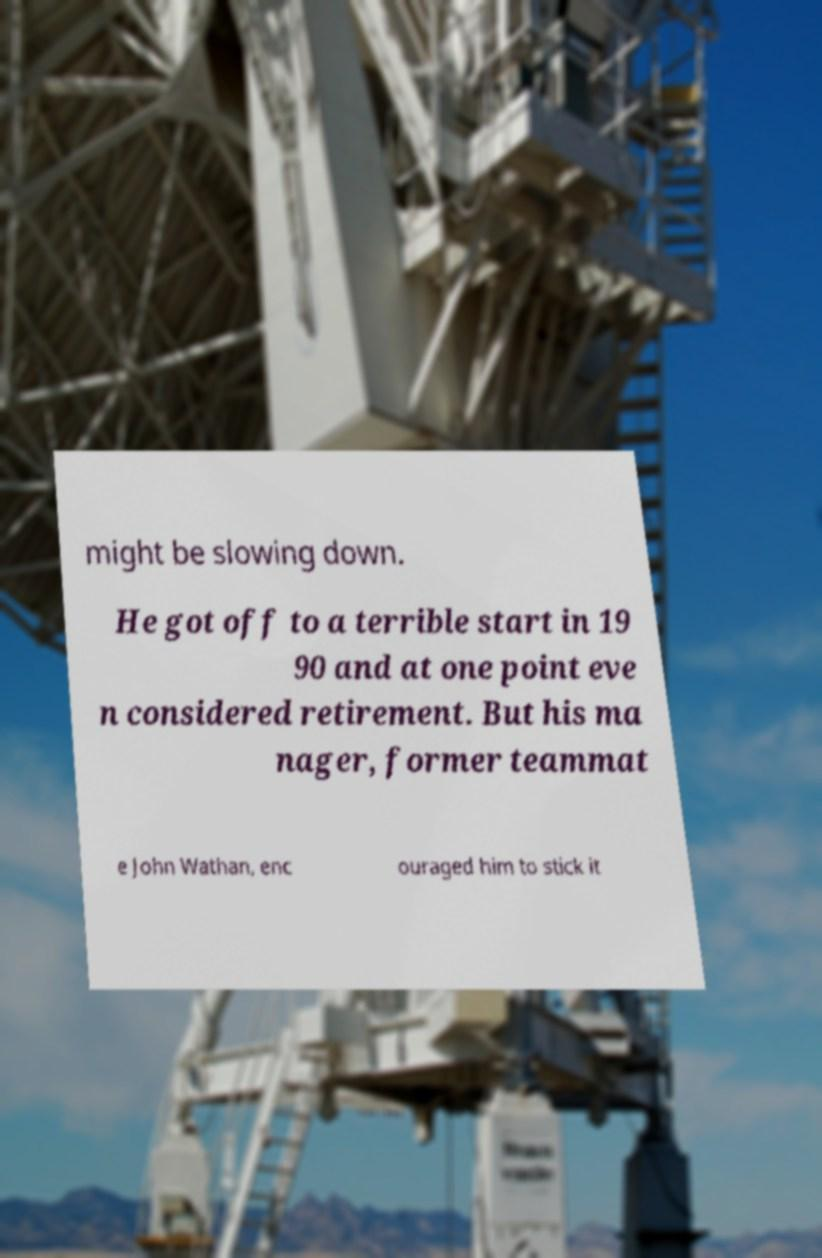Could you assist in decoding the text presented in this image and type it out clearly? might be slowing down. He got off to a terrible start in 19 90 and at one point eve n considered retirement. But his ma nager, former teammat e John Wathan, enc ouraged him to stick it 